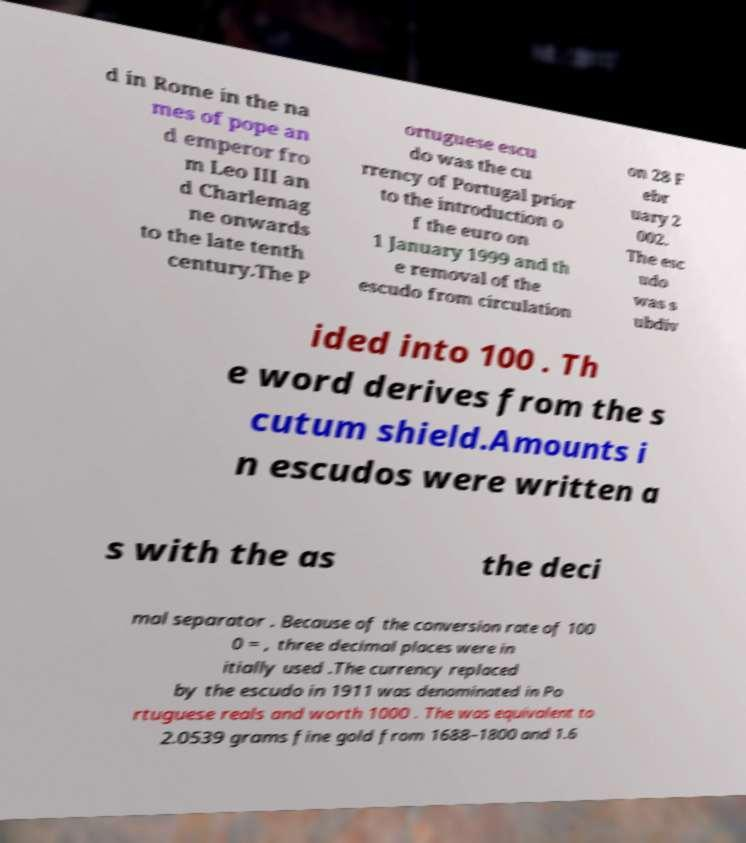Can you read and provide the text displayed in the image?This photo seems to have some interesting text. Can you extract and type it out for me? d in Rome in the na mes of pope an d emperor fro m Leo III an d Charlemag ne onwards to the late tenth century.The P ortuguese escu do was the cu rrency of Portugal prior to the introduction o f the euro on 1 January 1999 and th e removal of the escudo from circulation on 28 F ebr uary 2 002. The esc udo was s ubdiv ided into 100 . Th e word derives from the s cutum shield.Amounts i n escudos were written a s with the as the deci mal separator . Because of the conversion rate of 100 0 = , three decimal places were in itially used .The currency replaced by the escudo in 1911 was denominated in Po rtuguese reals and worth 1000 . The was equivalent to 2.0539 grams fine gold from 1688–1800 and 1.6 